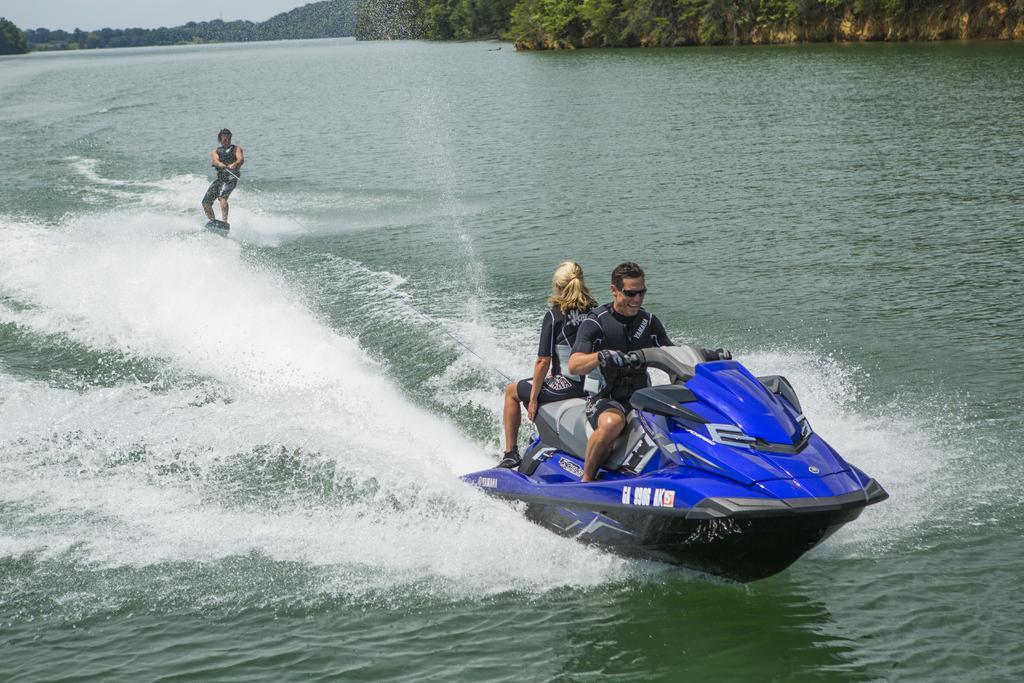Please provide a concise description of this image. This is an Ocean. Here I can see two persons are sitting on a personal watercraft. In the background there is another person surfing the board on the water. In the background there are many trees and hills. At the top of the image I can see the sky. 